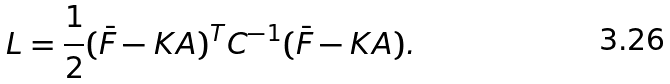Convert formula to latex. <formula><loc_0><loc_0><loc_500><loc_500>L = \frac { 1 } { 2 } ( \bar { F } - { K A } ) ^ { T } { C } ^ { - 1 } ( \bar { F } - { K A } ) .</formula> 